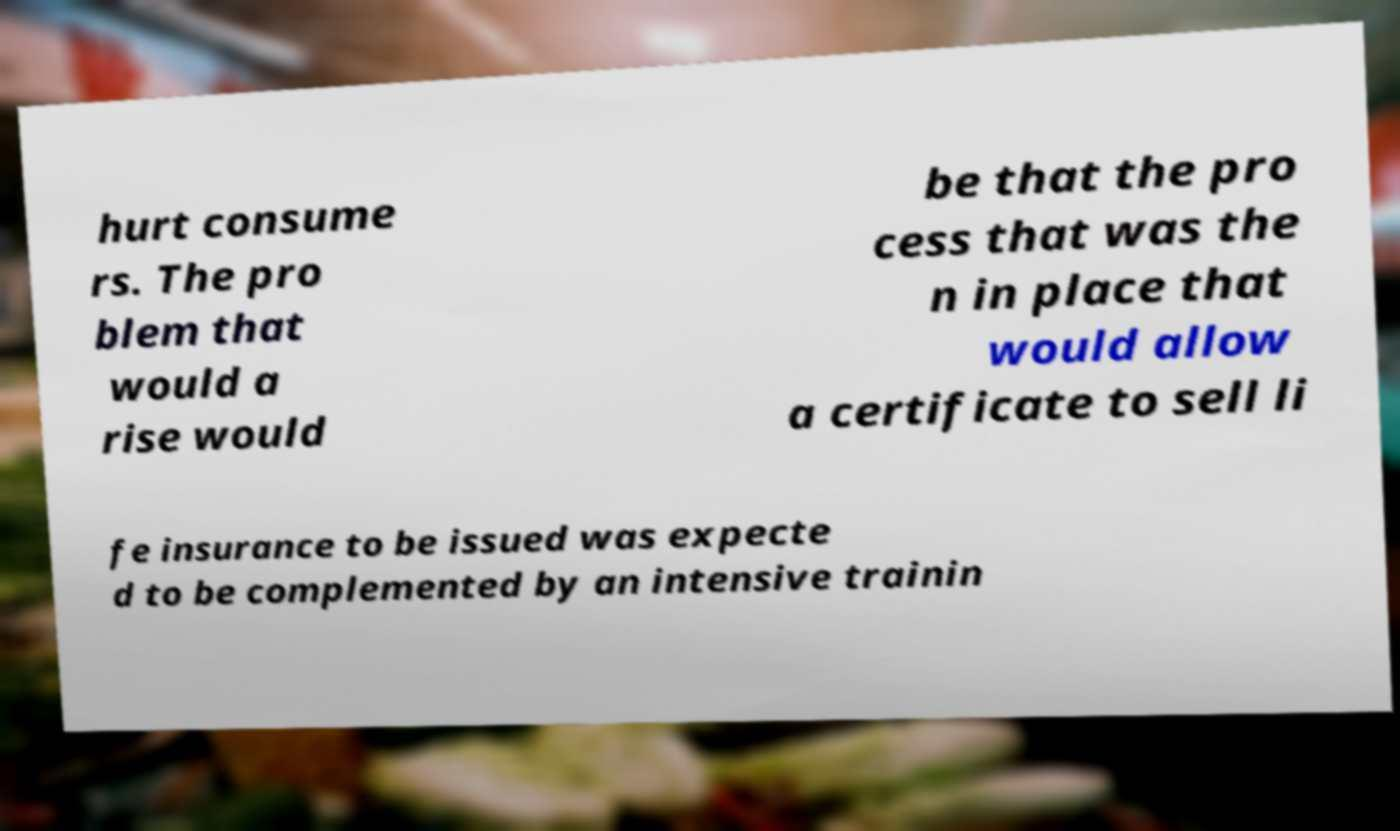Could you extract and type out the text from this image? hurt consume rs. The pro blem that would a rise would be that the pro cess that was the n in place that would allow a certificate to sell li fe insurance to be issued was expecte d to be complemented by an intensive trainin 